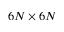Convert formula to latex. <formula><loc_0><loc_0><loc_500><loc_500>6 N \times 6 N</formula> 